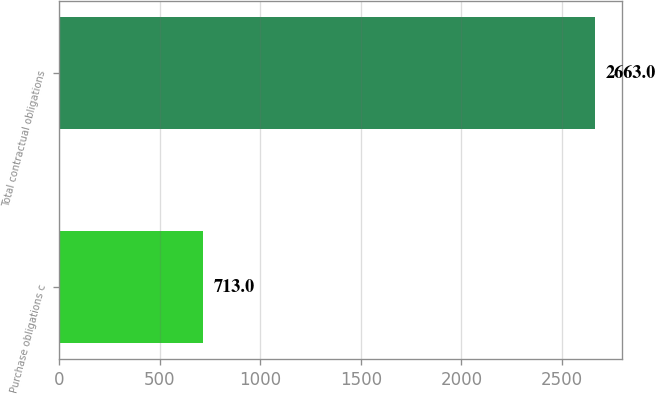Convert chart to OTSL. <chart><loc_0><loc_0><loc_500><loc_500><bar_chart><fcel>Purchase obligations c<fcel>Total contractual obligations<nl><fcel>713<fcel>2663<nl></chart> 